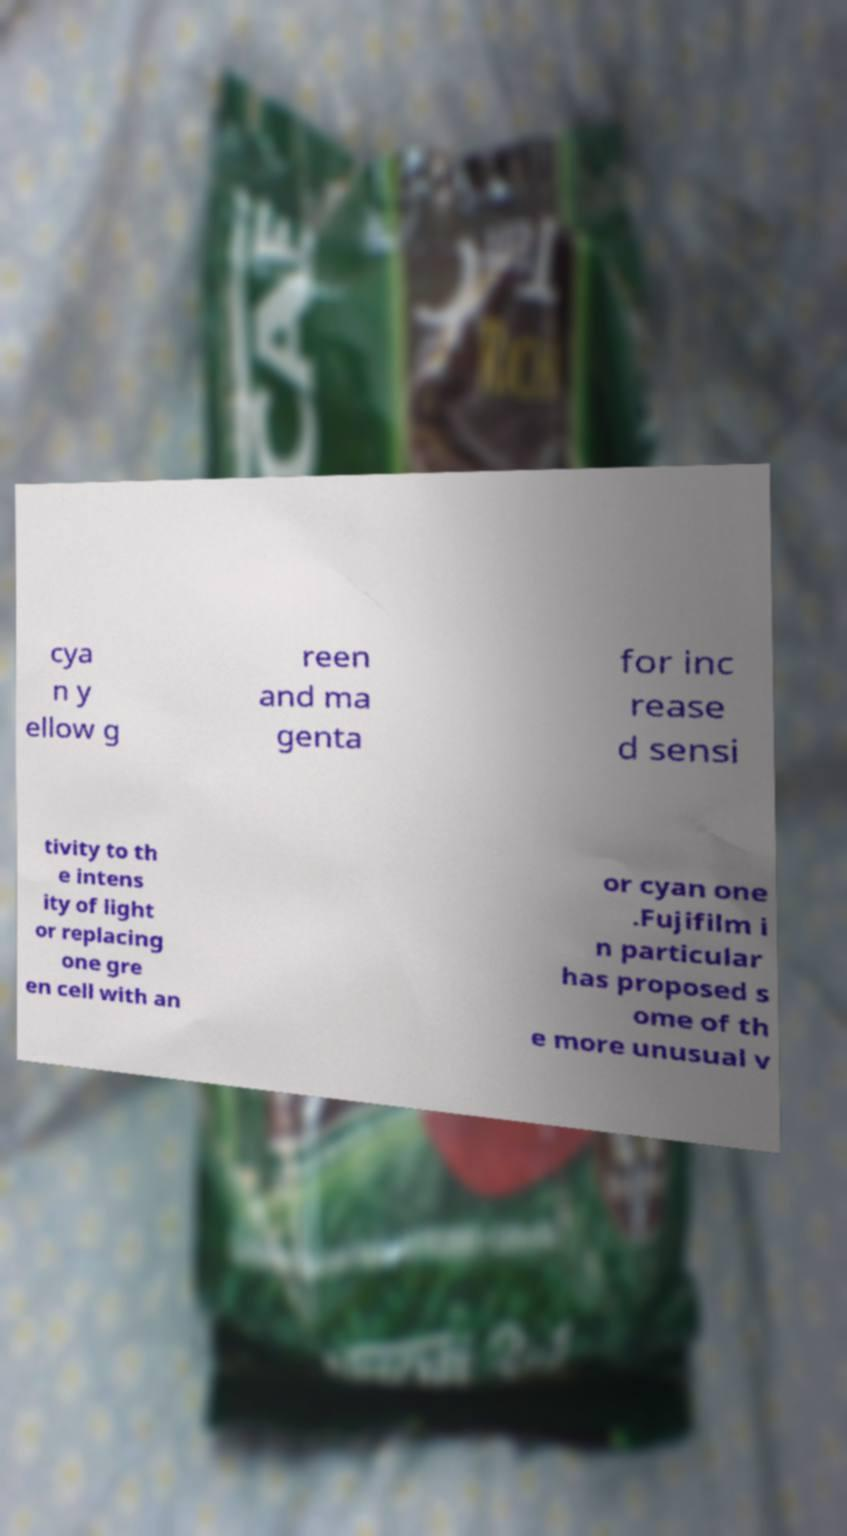I need the written content from this picture converted into text. Can you do that? cya n y ellow g reen and ma genta for inc rease d sensi tivity to th e intens ity of light or replacing one gre en cell with an or cyan one .Fujifilm i n particular has proposed s ome of th e more unusual v 